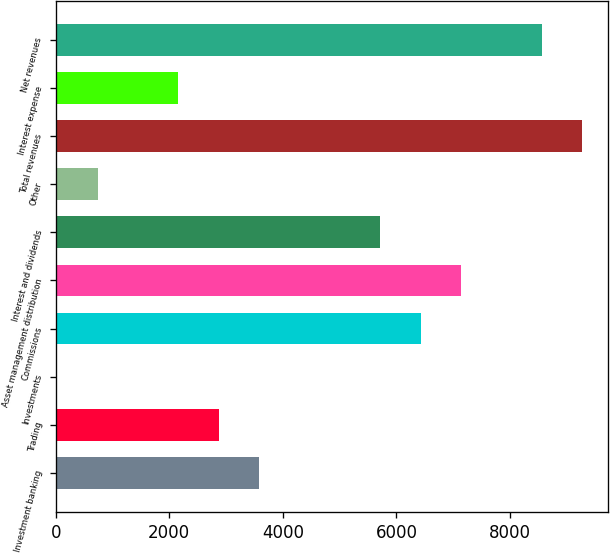Convert chart to OTSL. <chart><loc_0><loc_0><loc_500><loc_500><bar_chart><fcel>Investment banking<fcel>Trading<fcel>Investments<fcel>Commissions<fcel>Asset management distribution<fcel>Interest and dividends<fcel>Other<fcel>Total revenues<fcel>Interest expense<fcel>Net revenues<nl><fcel>3582.5<fcel>2871.8<fcel>29<fcel>6425.3<fcel>7136<fcel>5714.6<fcel>739.7<fcel>9268.1<fcel>2161.1<fcel>8557.4<nl></chart> 